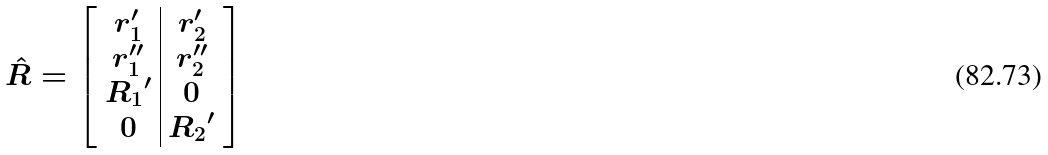<formula> <loc_0><loc_0><loc_500><loc_500>\hat { R } = \left [ \begin{array} { c | c } r _ { 1 } ^ { \prime } & r _ { 2 } ^ { \prime } \\ r _ { 1 } ^ { \prime \prime } & r _ { 2 } ^ { \prime \prime } \\ { R _ { 1 } } ^ { \prime } & 0 \\ 0 & { R _ { 2 } } ^ { \prime } \end{array} \right ]</formula> 